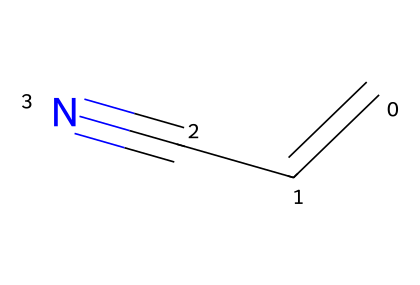What is the molecular formula of acrylonitrile? To determine the molecular formula, count the number of each type of atom in the structure: there are three carbon (C) atoms, three hydrogen (H) atoms, and one nitrogen (N) atom. Therefore, the molecular formula is C3H3N.
Answer: C3H3N How many double bonds are present in acrylonitrile? A double bond is represented by the "=" symbol in chemical structures. In acrylonitrile, there is one double bond between the first carbon and the second carbon.
Answer: 1 What type of functional group is present in acrylonitrile? The presence of a carbon-nitrogen triple bond (indicated by "C#N") identifies the nitrile functional group. Therefore, acrylonitrile contains a nitrile functional group.
Answer: nitrile What is the hybridization of the carbon atoms in acrylonitrile? Analyzing the structure, the first and second carbon atoms are involved in a double bond and are therefore sp² hybridized. The third carbon, which is connected to the nitrile group, is sp hybridized due to its connection to the nitrogen. Therefore, the hybridization of the carbon atoms is sp² for the first two and sp for the third.
Answer: sp² for C1 and C2; sp for C3 Is acrylonitrile a saturated or unsaturated compound? Saturated compounds contain only single bonds, while unsaturated compounds have one or more double or triple bonds. Acrylonitrile has a double bond between two carbons and a triple bond with nitrogen, which confirms it as an unsaturated compound.
Answer: unsaturated 